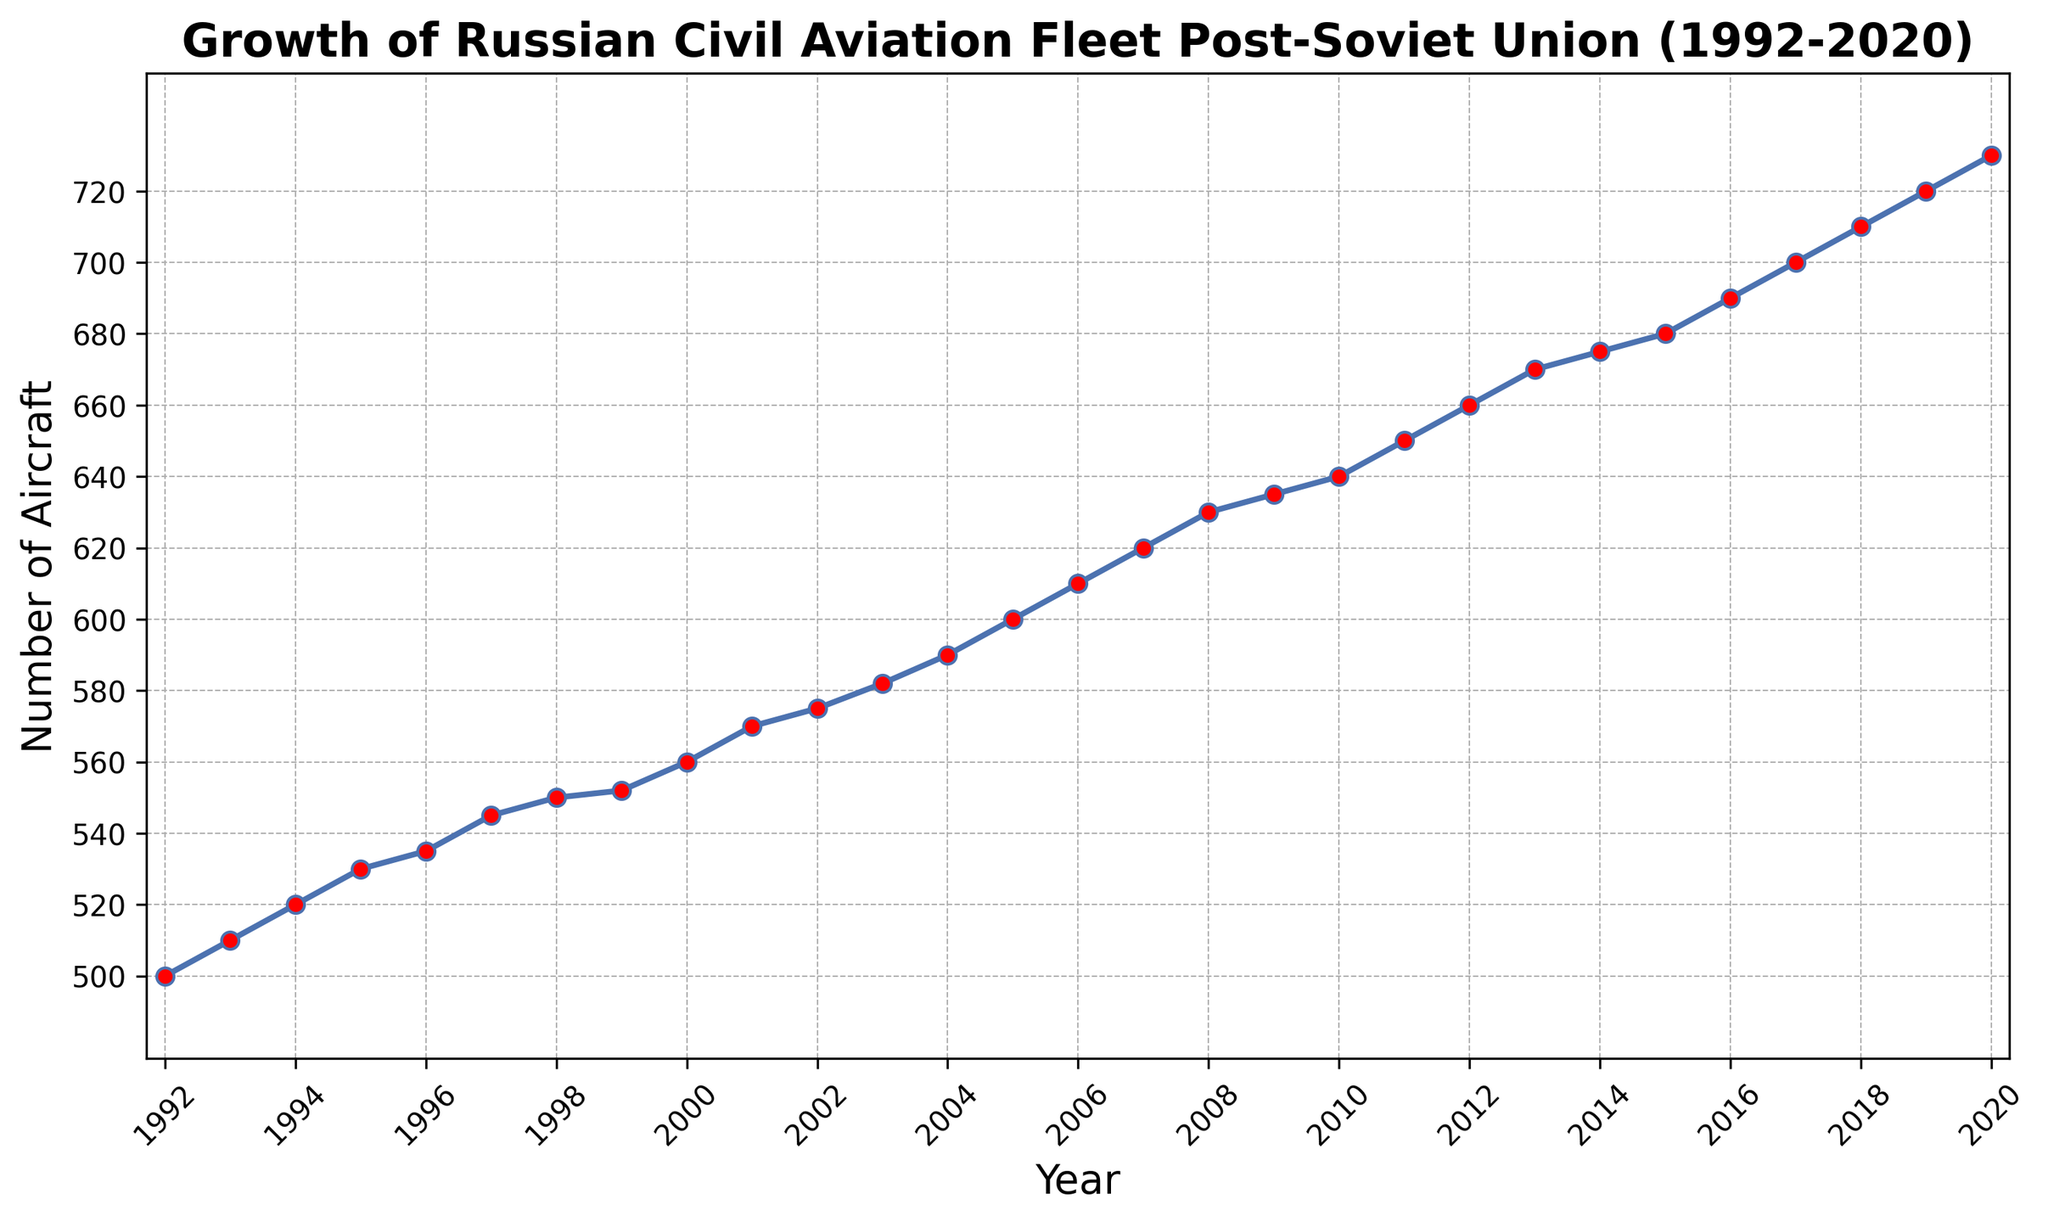What is the total increase in the number of aircraft from 1992 to 2020? The number of aircraft in 1992 was 500, and in 2020 it was 730. The total increase is calculated by subtracting the initial value from the final value: 730 - 500 = 230
Answer: 230 In which year did the number of aircraft first reach 600? By observing the data points on the line chart, the number of aircraft first reached 600 in the year 2005.
Answer: 2005 What is the average number of aircraft between 2000 and 2010? The number of aircraft from 2000 to 2010 are: 560, 570, 575, 582, 590, 600, 610, 620, 630, 635, and 640. The average is calculated by summing these numbers and dividing by the count, i.e., (560 + 570 + 575 + 582 + 590 + 600 + 610 + 620 + 630 + 635 + 640) / 11 = 6247 / 11 ≈ 568.82
Answer: ≈ 568.82 What is the year-over-year growth in the number of aircraft from 2010 to 2011? The number of aircraft in 2010 was 640, and in 2011 it was 650. The year-over-year growth is 650 - 640 = 10
Answer: 10 Between 1992 and 2020, in which periods did the growth rate appear to slow down, and how can you tell? From the line chart, the growth rate appears to slow down between approximately 1998 to 1999 and 2008 to 2009, where the rises in the number of aircraft are smaller or almost flat compared to other years.
Answer: 1998-1999 and 2008-2009 How does the growth from 1992 to 2002 compare to the growth from 2010 to 2020? The growth from 1992 to 2002 is the difference between 575 and 500, which is 75. The growth from 2010 to 2020 is the difference between 730 and 640, which is 90. Therefore, the growth from 2010 to 2020 is greater.
Answer: 90 > 75 What was the average annual growth rate of the number of aircraft from 1992 to 2020? The total increase from 1992 to 2020 is 230 aircraft over 28 years. The average annual growth rate is 230 / 28 ≈ 8.21 aircraft per year
Answer: ≈ 8.21 Are there any years where the number of aircraft decreased compared to the previous year? By examining the data points on the line chart, there are no years where the number of aircraft decreased compared to the previous year; it shows a consistent increase.
Answer: No When did the fleet size first exceed 700 aircraft? The fleet size first exceeded 700 aircraft in the year 2017.
Answer: 2017 